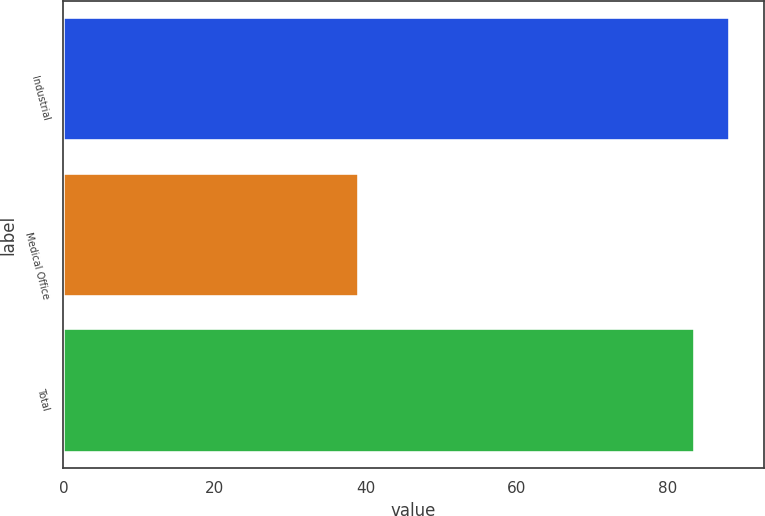Convert chart. <chart><loc_0><loc_0><loc_500><loc_500><bar_chart><fcel>Industrial<fcel>Medical Office<fcel>Total<nl><fcel>88.33<fcel>39.1<fcel>83.7<nl></chart> 